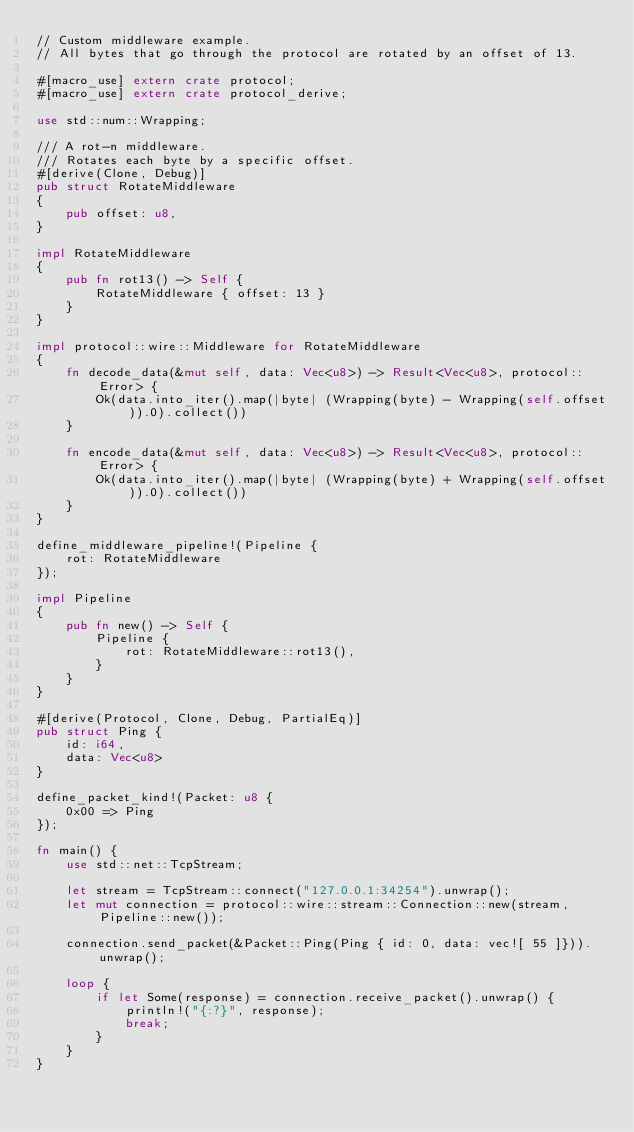Convert code to text. <code><loc_0><loc_0><loc_500><loc_500><_Rust_>// Custom middleware example.
// All bytes that go through the protocol are rotated by an offset of 13.

#[macro_use] extern crate protocol;
#[macro_use] extern crate protocol_derive;

use std::num::Wrapping;

/// A rot-n middleware.
/// Rotates each byte by a specific offset.
#[derive(Clone, Debug)]
pub struct RotateMiddleware
{
    pub offset: u8,
}

impl RotateMiddleware
{
    pub fn rot13() -> Self {
        RotateMiddleware { offset: 13 }
    }
}

impl protocol::wire::Middleware for RotateMiddleware
{
    fn decode_data(&mut self, data: Vec<u8>) -> Result<Vec<u8>, protocol::Error> {
        Ok(data.into_iter().map(|byte| (Wrapping(byte) - Wrapping(self.offset)).0).collect())
    }

    fn encode_data(&mut self, data: Vec<u8>) -> Result<Vec<u8>, protocol::Error> {
        Ok(data.into_iter().map(|byte| (Wrapping(byte) + Wrapping(self.offset)).0).collect())
    }
}

define_middleware_pipeline!(Pipeline {
    rot: RotateMiddleware
});

impl Pipeline
{
    pub fn new() -> Self {
        Pipeline {
            rot: RotateMiddleware::rot13(),
        }
    }
}

#[derive(Protocol, Clone, Debug, PartialEq)]
pub struct Ping {
    id: i64,
    data: Vec<u8>
}

define_packet_kind!(Packet: u8 {
    0x00 => Ping
});

fn main() {
    use std::net::TcpStream;

    let stream = TcpStream::connect("127.0.0.1:34254").unwrap();
    let mut connection = protocol::wire::stream::Connection::new(stream, Pipeline::new());

    connection.send_packet(&Packet::Ping(Ping { id: 0, data: vec![ 55 ]})).unwrap();

    loop {
        if let Some(response) = connection.receive_packet().unwrap() {
            println!("{:?}", response);
            break;
        }
    }
}

</code> 